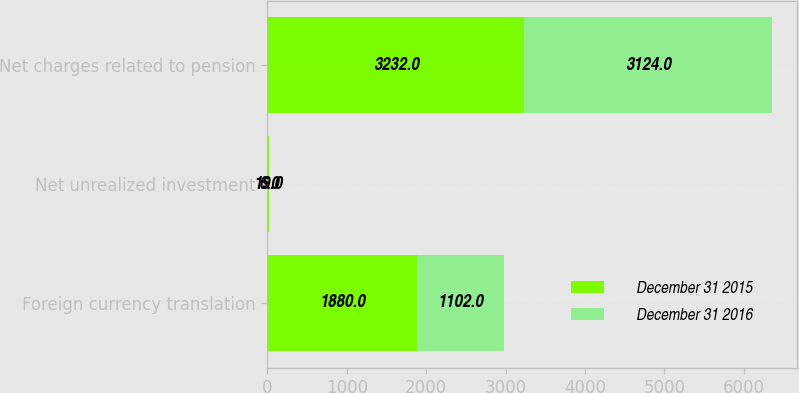Convert chart. <chart><loc_0><loc_0><loc_500><loc_500><stacked_bar_chart><ecel><fcel>Foreign currency translation<fcel>Net unrealized investment<fcel>Net charges related to pension<nl><fcel>December 31 2015<fcel>1880<fcel>19<fcel>3232<nl><fcel>December 31 2016<fcel>1102<fcel>6<fcel>3124<nl></chart> 